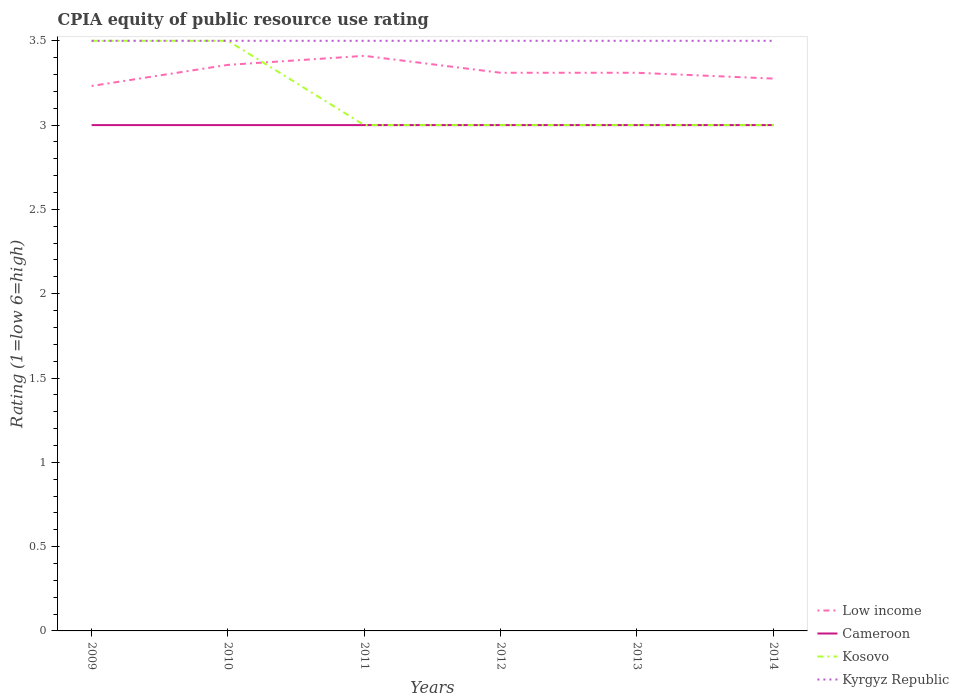How many different coloured lines are there?
Offer a terse response. 4. Is the number of lines equal to the number of legend labels?
Ensure brevity in your answer.  Yes. Across all years, what is the maximum CPIA rating in Cameroon?
Your answer should be very brief. 3. What is the total CPIA rating in Cameroon in the graph?
Provide a succinct answer. 0. What is the difference between the highest and the second highest CPIA rating in Kosovo?
Ensure brevity in your answer.  0.5. Is the CPIA rating in Kyrgyz Republic strictly greater than the CPIA rating in Cameroon over the years?
Your answer should be compact. No. Are the values on the major ticks of Y-axis written in scientific E-notation?
Keep it short and to the point. No. How many legend labels are there?
Provide a short and direct response. 4. What is the title of the graph?
Your response must be concise. CPIA equity of public resource use rating. What is the label or title of the X-axis?
Give a very brief answer. Years. What is the label or title of the Y-axis?
Offer a terse response. Rating (1=low 6=high). What is the Rating (1=low 6=high) in Low income in 2009?
Ensure brevity in your answer.  3.23. What is the Rating (1=low 6=high) of Cameroon in 2009?
Make the answer very short. 3. What is the Rating (1=low 6=high) of Low income in 2010?
Offer a very short reply. 3.36. What is the Rating (1=low 6=high) in Kyrgyz Republic in 2010?
Give a very brief answer. 3.5. What is the Rating (1=low 6=high) of Low income in 2011?
Provide a short and direct response. 3.41. What is the Rating (1=low 6=high) in Kyrgyz Republic in 2011?
Keep it short and to the point. 3.5. What is the Rating (1=low 6=high) in Low income in 2012?
Your answer should be very brief. 3.31. What is the Rating (1=low 6=high) of Cameroon in 2012?
Keep it short and to the point. 3. What is the Rating (1=low 6=high) of Kosovo in 2012?
Your answer should be compact. 3. What is the Rating (1=low 6=high) of Kyrgyz Republic in 2012?
Your answer should be very brief. 3.5. What is the Rating (1=low 6=high) in Low income in 2013?
Provide a short and direct response. 3.31. What is the Rating (1=low 6=high) in Kosovo in 2013?
Your answer should be very brief. 3. What is the Rating (1=low 6=high) of Kyrgyz Republic in 2013?
Give a very brief answer. 3.5. What is the Rating (1=low 6=high) in Low income in 2014?
Offer a very short reply. 3.28. What is the Rating (1=low 6=high) in Kosovo in 2014?
Make the answer very short. 3. What is the Rating (1=low 6=high) of Kyrgyz Republic in 2014?
Your response must be concise. 3.5. Across all years, what is the maximum Rating (1=low 6=high) in Low income?
Your answer should be compact. 3.41. Across all years, what is the maximum Rating (1=low 6=high) of Cameroon?
Make the answer very short. 3. Across all years, what is the minimum Rating (1=low 6=high) in Low income?
Keep it short and to the point. 3.23. Across all years, what is the minimum Rating (1=low 6=high) of Cameroon?
Keep it short and to the point. 3. Across all years, what is the minimum Rating (1=low 6=high) of Kyrgyz Republic?
Your response must be concise. 3.5. What is the total Rating (1=low 6=high) in Low income in the graph?
Your answer should be compact. 19.9. What is the total Rating (1=low 6=high) in Kyrgyz Republic in the graph?
Offer a very short reply. 21. What is the difference between the Rating (1=low 6=high) in Low income in 2009 and that in 2010?
Offer a very short reply. -0.12. What is the difference between the Rating (1=low 6=high) of Kosovo in 2009 and that in 2010?
Your answer should be very brief. 0. What is the difference between the Rating (1=low 6=high) of Kyrgyz Republic in 2009 and that in 2010?
Provide a short and direct response. 0. What is the difference between the Rating (1=low 6=high) of Low income in 2009 and that in 2011?
Keep it short and to the point. -0.18. What is the difference between the Rating (1=low 6=high) in Kosovo in 2009 and that in 2011?
Offer a very short reply. 0.5. What is the difference between the Rating (1=low 6=high) in Low income in 2009 and that in 2012?
Offer a terse response. -0.08. What is the difference between the Rating (1=low 6=high) in Cameroon in 2009 and that in 2012?
Offer a very short reply. 0. What is the difference between the Rating (1=low 6=high) in Kyrgyz Republic in 2009 and that in 2012?
Offer a terse response. 0. What is the difference between the Rating (1=low 6=high) of Low income in 2009 and that in 2013?
Give a very brief answer. -0.08. What is the difference between the Rating (1=low 6=high) in Cameroon in 2009 and that in 2013?
Your answer should be very brief. 0. What is the difference between the Rating (1=low 6=high) in Kosovo in 2009 and that in 2013?
Ensure brevity in your answer.  0.5. What is the difference between the Rating (1=low 6=high) of Kyrgyz Republic in 2009 and that in 2013?
Make the answer very short. 0. What is the difference between the Rating (1=low 6=high) of Low income in 2009 and that in 2014?
Keep it short and to the point. -0.04. What is the difference between the Rating (1=low 6=high) in Low income in 2010 and that in 2011?
Your response must be concise. -0.05. What is the difference between the Rating (1=low 6=high) in Kyrgyz Republic in 2010 and that in 2011?
Offer a terse response. 0. What is the difference between the Rating (1=low 6=high) in Low income in 2010 and that in 2012?
Provide a succinct answer. 0.05. What is the difference between the Rating (1=low 6=high) of Cameroon in 2010 and that in 2012?
Your response must be concise. 0. What is the difference between the Rating (1=low 6=high) in Kyrgyz Republic in 2010 and that in 2012?
Your answer should be compact. 0. What is the difference between the Rating (1=low 6=high) of Low income in 2010 and that in 2013?
Offer a terse response. 0.05. What is the difference between the Rating (1=low 6=high) in Cameroon in 2010 and that in 2013?
Make the answer very short. 0. What is the difference between the Rating (1=low 6=high) in Low income in 2010 and that in 2014?
Your answer should be very brief. 0.08. What is the difference between the Rating (1=low 6=high) in Kosovo in 2010 and that in 2014?
Your response must be concise. 0.5. What is the difference between the Rating (1=low 6=high) in Low income in 2011 and that in 2012?
Your answer should be compact. 0.1. What is the difference between the Rating (1=low 6=high) of Cameroon in 2011 and that in 2012?
Your response must be concise. 0. What is the difference between the Rating (1=low 6=high) of Low income in 2011 and that in 2013?
Your answer should be very brief. 0.1. What is the difference between the Rating (1=low 6=high) of Cameroon in 2011 and that in 2013?
Provide a short and direct response. 0. What is the difference between the Rating (1=low 6=high) in Kyrgyz Republic in 2011 and that in 2013?
Keep it short and to the point. 0. What is the difference between the Rating (1=low 6=high) in Low income in 2011 and that in 2014?
Your response must be concise. 0.13. What is the difference between the Rating (1=low 6=high) of Cameroon in 2011 and that in 2014?
Keep it short and to the point. 0. What is the difference between the Rating (1=low 6=high) in Kosovo in 2011 and that in 2014?
Offer a very short reply. 0. What is the difference between the Rating (1=low 6=high) in Kyrgyz Republic in 2011 and that in 2014?
Ensure brevity in your answer.  0. What is the difference between the Rating (1=low 6=high) in Kosovo in 2012 and that in 2013?
Ensure brevity in your answer.  0. What is the difference between the Rating (1=low 6=high) of Low income in 2012 and that in 2014?
Your answer should be compact. 0.03. What is the difference between the Rating (1=low 6=high) in Kosovo in 2012 and that in 2014?
Ensure brevity in your answer.  0. What is the difference between the Rating (1=low 6=high) in Low income in 2013 and that in 2014?
Keep it short and to the point. 0.03. What is the difference between the Rating (1=low 6=high) of Cameroon in 2013 and that in 2014?
Provide a short and direct response. 0. What is the difference between the Rating (1=low 6=high) of Kyrgyz Republic in 2013 and that in 2014?
Keep it short and to the point. 0. What is the difference between the Rating (1=low 6=high) of Low income in 2009 and the Rating (1=low 6=high) of Cameroon in 2010?
Provide a short and direct response. 0.23. What is the difference between the Rating (1=low 6=high) of Low income in 2009 and the Rating (1=low 6=high) of Kosovo in 2010?
Offer a terse response. -0.27. What is the difference between the Rating (1=low 6=high) of Low income in 2009 and the Rating (1=low 6=high) of Kyrgyz Republic in 2010?
Your response must be concise. -0.27. What is the difference between the Rating (1=low 6=high) in Kosovo in 2009 and the Rating (1=low 6=high) in Kyrgyz Republic in 2010?
Offer a terse response. 0. What is the difference between the Rating (1=low 6=high) of Low income in 2009 and the Rating (1=low 6=high) of Cameroon in 2011?
Provide a succinct answer. 0.23. What is the difference between the Rating (1=low 6=high) of Low income in 2009 and the Rating (1=low 6=high) of Kosovo in 2011?
Make the answer very short. 0.23. What is the difference between the Rating (1=low 6=high) of Low income in 2009 and the Rating (1=low 6=high) of Kyrgyz Republic in 2011?
Your response must be concise. -0.27. What is the difference between the Rating (1=low 6=high) of Cameroon in 2009 and the Rating (1=low 6=high) of Kosovo in 2011?
Offer a very short reply. 0. What is the difference between the Rating (1=low 6=high) of Cameroon in 2009 and the Rating (1=low 6=high) of Kyrgyz Republic in 2011?
Your answer should be very brief. -0.5. What is the difference between the Rating (1=low 6=high) of Kosovo in 2009 and the Rating (1=low 6=high) of Kyrgyz Republic in 2011?
Provide a short and direct response. 0. What is the difference between the Rating (1=low 6=high) of Low income in 2009 and the Rating (1=low 6=high) of Cameroon in 2012?
Ensure brevity in your answer.  0.23. What is the difference between the Rating (1=low 6=high) of Low income in 2009 and the Rating (1=low 6=high) of Kosovo in 2012?
Provide a succinct answer. 0.23. What is the difference between the Rating (1=low 6=high) in Low income in 2009 and the Rating (1=low 6=high) in Kyrgyz Republic in 2012?
Provide a short and direct response. -0.27. What is the difference between the Rating (1=low 6=high) of Cameroon in 2009 and the Rating (1=low 6=high) of Kyrgyz Republic in 2012?
Provide a short and direct response. -0.5. What is the difference between the Rating (1=low 6=high) in Low income in 2009 and the Rating (1=low 6=high) in Cameroon in 2013?
Keep it short and to the point. 0.23. What is the difference between the Rating (1=low 6=high) in Low income in 2009 and the Rating (1=low 6=high) in Kosovo in 2013?
Provide a short and direct response. 0.23. What is the difference between the Rating (1=low 6=high) of Low income in 2009 and the Rating (1=low 6=high) of Kyrgyz Republic in 2013?
Your answer should be compact. -0.27. What is the difference between the Rating (1=low 6=high) of Cameroon in 2009 and the Rating (1=low 6=high) of Kosovo in 2013?
Ensure brevity in your answer.  0. What is the difference between the Rating (1=low 6=high) in Cameroon in 2009 and the Rating (1=low 6=high) in Kyrgyz Republic in 2013?
Your response must be concise. -0.5. What is the difference between the Rating (1=low 6=high) in Low income in 2009 and the Rating (1=low 6=high) in Cameroon in 2014?
Give a very brief answer. 0.23. What is the difference between the Rating (1=low 6=high) of Low income in 2009 and the Rating (1=low 6=high) of Kosovo in 2014?
Ensure brevity in your answer.  0.23. What is the difference between the Rating (1=low 6=high) of Low income in 2009 and the Rating (1=low 6=high) of Kyrgyz Republic in 2014?
Your answer should be very brief. -0.27. What is the difference between the Rating (1=low 6=high) in Low income in 2010 and the Rating (1=low 6=high) in Cameroon in 2011?
Offer a terse response. 0.36. What is the difference between the Rating (1=low 6=high) of Low income in 2010 and the Rating (1=low 6=high) of Kosovo in 2011?
Your response must be concise. 0.36. What is the difference between the Rating (1=low 6=high) of Low income in 2010 and the Rating (1=low 6=high) of Kyrgyz Republic in 2011?
Your answer should be compact. -0.14. What is the difference between the Rating (1=low 6=high) of Cameroon in 2010 and the Rating (1=low 6=high) of Kosovo in 2011?
Ensure brevity in your answer.  0. What is the difference between the Rating (1=low 6=high) in Kosovo in 2010 and the Rating (1=low 6=high) in Kyrgyz Republic in 2011?
Your response must be concise. 0. What is the difference between the Rating (1=low 6=high) of Low income in 2010 and the Rating (1=low 6=high) of Cameroon in 2012?
Make the answer very short. 0.36. What is the difference between the Rating (1=low 6=high) of Low income in 2010 and the Rating (1=low 6=high) of Kosovo in 2012?
Keep it short and to the point. 0.36. What is the difference between the Rating (1=low 6=high) in Low income in 2010 and the Rating (1=low 6=high) in Kyrgyz Republic in 2012?
Your answer should be compact. -0.14. What is the difference between the Rating (1=low 6=high) in Cameroon in 2010 and the Rating (1=low 6=high) in Kyrgyz Republic in 2012?
Give a very brief answer. -0.5. What is the difference between the Rating (1=low 6=high) of Low income in 2010 and the Rating (1=low 6=high) of Cameroon in 2013?
Provide a succinct answer. 0.36. What is the difference between the Rating (1=low 6=high) of Low income in 2010 and the Rating (1=low 6=high) of Kosovo in 2013?
Offer a terse response. 0.36. What is the difference between the Rating (1=low 6=high) of Low income in 2010 and the Rating (1=low 6=high) of Kyrgyz Republic in 2013?
Make the answer very short. -0.14. What is the difference between the Rating (1=low 6=high) in Cameroon in 2010 and the Rating (1=low 6=high) in Kosovo in 2013?
Provide a short and direct response. 0. What is the difference between the Rating (1=low 6=high) in Kosovo in 2010 and the Rating (1=low 6=high) in Kyrgyz Republic in 2013?
Your answer should be compact. 0. What is the difference between the Rating (1=low 6=high) in Low income in 2010 and the Rating (1=low 6=high) in Cameroon in 2014?
Your response must be concise. 0.36. What is the difference between the Rating (1=low 6=high) in Low income in 2010 and the Rating (1=low 6=high) in Kosovo in 2014?
Ensure brevity in your answer.  0.36. What is the difference between the Rating (1=low 6=high) in Low income in 2010 and the Rating (1=low 6=high) in Kyrgyz Republic in 2014?
Make the answer very short. -0.14. What is the difference between the Rating (1=low 6=high) of Cameroon in 2010 and the Rating (1=low 6=high) of Kyrgyz Republic in 2014?
Your response must be concise. -0.5. What is the difference between the Rating (1=low 6=high) in Low income in 2011 and the Rating (1=low 6=high) in Cameroon in 2012?
Offer a very short reply. 0.41. What is the difference between the Rating (1=low 6=high) in Low income in 2011 and the Rating (1=low 6=high) in Kosovo in 2012?
Provide a succinct answer. 0.41. What is the difference between the Rating (1=low 6=high) in Low income in 2011 and the Rating (1=low 6=high) in Kyrgyz Republic in 2012?
Ensure brevity in your answer.  -0.09. What is the difference between the Rating (1=low 6=high) in Kosovo in 2011 and the Rating (1=low 6=high) in Kyrgyz Republic in 2012?
Ensure brevity in your answer.  -0.5. What is the difference between the Rating (1=low 6=high) in Low income in 2011 and the Rating (1=low 6=high) in Cameroon in 2013?
Keep it short and to the point. 0.41. What is the difference between the Rating (1=low 6=high) of Low income in 2011 and the Rating (1=low 6=high) of Kosovo in 2013?
Provide a short and direct response. 0.41. What is the difference between the Rating (1=low 6=high) in Low income in 2011 and the Rating (1=low 6=high) in Kyrgyz Republic in 2013?
Give a very brief answer. -0.09. What is the difference between the Rating (1=low 6=high) of Kosovo in 2011 and the Rating (1=low 6=high) of Kyrgyz Republic in 2013?
Make the answer very short. -0.5. What is the difference between the Rating (1=low 6=high) in Low income in 2011 and the Rating (1=low 6=high) in Cameroon in 2014?
Keep it short and to the point. 0.41. What is the difference between the Rating (1=low 6=high) in Low income in 2011 and the Rating (1=low 6=high) in Kosovo in 2014?
Your answer should be very brief. 0.41. What is the difference between the Rating (1=low 6=high) in Low income in 2011 and the Rating (1=low 6=high) in Kyrgyz Republic in 2014?
Offer a terse response. -0.09. What is the difference between the Rating (1=low 6=high) of Low income in 2012 and the Rating (1=low 6=high) of Cameroon in 2013?
Make the answer very short. 0.31. What is the difference between the Rating (1=low 6=high) of Low income in 2012 and the Rating (1=low 6=high) of Kosovo in 2013?
Give a very brief answer. 0.31. What is the difference between the Rating (1=low 6=high) of Low income in 2012 and the Rating (1=low 6=high) of Kyrgyz Republic in 2013?
Offer a terse response. -0.19. What is the difference between the Rating (1=low 6=high) of Cameroon in 2012 and the Rating (1=low 6=high) of Kyrgyz Republic in 2013?
Keep it short and to the point. -0.5. What is the difference between the Rating (1=low 6=high) in Kosovo in 2012 and the Rating (1=low 6=high) in Kyrgyz Republic in 2013?
Your answer should be compact. -0.5. What is the difference between the Rating (1=low 6=high) of Low income in 2012 and the Rating (1=low 6=high) of Cameroon in 2014?
Keep it short and to the point. 0.31. What is the difference between the Rating (1=low 6=high) in Low income in 2012 and the Rating (1=low 6=high) in Kosovo in 2014?
Offer a terse response. 0.31. What is the difference between the Rating (1=low 6=high) of Low income in 2012 and the Rating (1=low 6=high) of Kyrgyz Republic in 2014?
Offer a very short reply. -0.19. What is the difference between the Rating (1=low 6=high) of Kosovo in 2012 and the Rating (1=low 6=high) of Kyrgyz Republic in 2014?
Offer a very short reply. -0.5. What is the difference between the Rating (1=low 6=high) in Low income in 2013 and the Rating (1=low 6=high) in Cameroon in 2014?
Give a very brief answer. 0.31. What is the difference between the Rating (1=low 6=high) in Low income in 2013 and the Rating (1=low 6=high) in Kosovo in 2014?
Make the answer very short. 0.31. What is the difference between the Rating (1=low 6=high) in Low income in 2013 and the Rating (1=low 6=high) in Kyrgyz Republic in 2014?
Your answer should be compact. -0.19. What is the average Rating (1=low 6=high) of Low income per year?
Ensure brevity in your answer.  3.32. What is the average Rating (1=low 6=high) in Cameroon per year?
Provide a short and direct response. 3. What is the average Rating (1=low 6=high) in Kosovo per year?
Provide a short and direct response. 3.17. In the year 2009, what is the difference between the Rating (1=low 6=high) in Low income and Rating (1=low 6=high) in Cameroon?
Provide a short and direct response. 0.23. In the year 2009, what is the difference between the Rating (1=low 6=high) of Low income and Rating (1=low 6=high) of Kosovo?
Provide a short and direct response. -0.27. In the year 2009, what is the difference between the Rating (1=low 6=high) in Low income and Rating (1=low 6=high) in Kyrgyz Republic?
Make the answer very short. -0.27. In the year 2009, what is the difference between the Rating (1=low 6=high) of Cameroon and Rating (1=low 6=high) of Kosovo?
Ensure brevity in your answer.  -0.5. In the year 2009, what is the difference between the Rating (1=low 6=high) of Kosovo and Rating (1=low 6=high) of Kyrgyz Republic?
Offer a very short reply. 0. In the year 2010, what is the difference between the Rating (1=low 6=high) of Low income and Rating (1=low 6=high) of Cameroon?
Keep it short and to the point. 0.36. In the year 2010, what is the difference between the Rating (1=low 6=high) in Low income and Rating (1=low 6=high) in Kosovo?
Your answer should be compact. -0.14. In the year 2010, what is the difference between the Rating (1=low 6=high) in Low income and Rating (1=low 6=high) in Kyrgyz Republic?
Provide a succinct answer. -0.14. In the year 2010, what is the difference between the Rating (1=low 6=high) in Cameroon and Rating (1=low 6=high) in Kosovo?
Keep it short and to the point. -0.5. In the year 2011, what is the difference between the Rating (1=low 6=high) in Low income and Rating (1=low 6=high) in Cameroon?
Provide a short and direct response. 0.41. In the year 2011, what is the difference between the Rating (1=low 6=high) in Low income and Rating (1=low 6=high) in Kosovo?
Ensure brevity in your answer.  0.41. In the year 2011, what is the difference between the Rating (1=low 6=high) of Low income and Rating (1=low 6=high) of Kyrgyz Republic?
Provide a succinct answer. -0.09. In the year 2011, what is the difference between the Rating (1=low 6=high) of Cameroon and Rating (1=low 6=high) of Kosovo?
Give a very brief answer. 0. In the year 2012, what is the difference between the Rating (1=low 6=high) of Low income and Rating (1=low 6=high) of Cameroon?
Provide a short and direct response. 0.31. In the year 2012, what is the difference between the Rating (1=low 6=high) of Low income and Rating (1=low 6=high) of Kosovo?
Make the answer very short. 0.31. In the year 2012, what is the difference between the Rating (1=low 6=high) in Low income and Rating (1=low 6=high) in Kyrgyz Republic?
Ensure brevity in your answer.  -0.19. In the year 2012, what is the difference between the Rating (1=low 6=high) of Cameroon and Rating (1=low 6=high) of Kosovo?
Your answer should be very brief. 0. In the year 2012, what is the difference between the Rating (1=low 6=high) in Cameroon and Rating (1=low 6=high) in Kyrgyz Republic?
Provide a succinct answer. -0.5. In the year 2013, what is the difference between the Rating (1=low 6=high) of Low income and Rating (1=low 6=high) of Cameroon?
Provide a succinct answer. 0.31. In the year 2013, what is the difference between the Rating (1=low 6=high) of Low income and Rating (1=low 6=high) of Kosovo?
Your answer should be compact. 0.31. In the year 2013, what is the difference between the Rating (1=low 6=high) in Low income and Rating (1=low 6=high) in Kyrgyz Republic?
Provide a succinct answer. -0.19. In the year 2014, what is the difference between the Rating (1=low 6=high) in Low income and Rating (1=low 6=high) in Cameroon?
Give a very brief answer. 0.28. In the year 2014, what is the difference between the Rating (1=low 6=high) of Low income and Rating (1=low 6=high) of Kosovo?
Offer a terse response. 0.28. In the year 2014, what is the difference between the Rating (1=low 6=high) in Low income and Rating (1=low 6=high) in Kyrgyz Republic?
Provide a short and direct response. -0.22. In the year 2014, what is the difference between the Rating (1=low 6=high) of Cameroon and Rating (1=low 6=high) of Kosovo?
Give a very brief answer. 0. In the year 2014, what is the difference between the Rating (1=low 6=high) of Cameroon and Rating (1=low 6=high) of Kyrgyz Republic?
Give a very brief answer. -0.5. In the year 2014, what is the difference between the Rating (1=low 6=high) in Kosovo and Rating (1=low 6=high) in Kyrgyz Republic?
Provide a succinct answer. -0.5. What is the ratio of the Rating (1=low 6=high) of Low income in 2009 to that in 2010?
Make the answer very short. 0.96. What is the ratio of the Rating (1=low 6=high) in Kyrgyz Republic in 2009 to that in 2010?
Make the answer very short. 1. What is the ratio of the Rating (1=low 6=high) in Low income in 2009 to that in 2011?
Provide a succinct answer. 0.95. What is the ratio of the Rating (1=low 6=high) in Cameroon in 2009 to that in 2011?
Your answer should be compact. 1. What is the ratio of the Rating (1=low 6=high) of Kyrgyz Republic in 2009 to that in 2011?
Give a very brief answer. 1. What is the ratio of the Rating (1=low 6=high) of Low income in 2009 to that in 2012?
Give a very brief answer. 0.98. What is the ratio of the Rating (1=low 6=high) of Cameroon in 2009 to that in 2012?
Make the answer very short. 1. What is the ratio of the Rating (1=low 6=high) in Kyrgyz Republic in 2009 to that in 2012?
Offer a terse response. 1. What is the ratio of the Rating (1=low 6=high) of Low income in 2009 to that in 2013?
Your answer should be very brief. 0.98. What is the ratio of the Rating (1=low 6=high) in Kosovo in 2009 to that in 2013?
Keep it short and to the point. 1.17. What is the ratio of the Rating (1=low 6=high) of Kyrgyz Republic in 2009 to that in 2013?
Your answer should be compact. 1. What is the ratio of the Rating (1=low 6=high) of Low income in 2009 to that in 2014?
Your answer should be compact. 0.99. What is the ratio of the Rating (1=low 6=high) in Cameroon in 2009 to that in 2014?
Ensure brevity in your answer.  1. What is the ratio of the Rating (1=low 6=high) in Low income in 2010 to that in 2011?
Offer a very short reply. 0.98. What is the ratio of the Rating (1=low 6=high) in Cameroon in 2010 to that in 2011?
Ensure brevity in your answer.  1. What is the ratio of the Rating (1=low 6=high) of Low income in 2010 to that in 2012?
Make the answer very short. 1.01. What is the ratio of the Rating (1=low 6=high) of Cameroon in 2010 to that in 2012?
Your answer should be compact. 1. What is the ratio of the Rating (1=low 6=high) of Low income in 2010 to that in 2013?
Ensure brevity in your answer.  1.01. What is the ratio of the Rating (1=low 6=high) in Low income in 2010 to that in 2014?
Your answer should be compact. 1.02. What is the ratio of the Rating (1=low 6=high) in Cameroon in 2010 to that in 2014?
Your answer should be compact. 1. What is the ratio of the Rating (1=low 6=high) of Kyrgyz Republic in 2010 to that in 2014?
Provide a succinct answer. 1. What is the ratio of the Rating (1=low 6=high) of Low income in 2011 to that in 2012?
Your answer should be very brief. 1.03. What is the ratio of the Rating (1=low 6=high) in Cameroon in 2011 to that in 2012?
Your response must be concise. 1. What is the ratio of the Rating (1=low 6=high) of Low income in 2011 to that in 2013?
Provide a succinct answer. 1.03. What is the ratio of the Rating (1=low 6=high) in Kosovo in 2011 to that in 2013?
Give a very brief answer. 1. What is the ratio of the Rating (1=low 6=high) in Kyrgyz Republic in 2011 to that in 2013?
Give a very brief answer. 1. What is the ratio of the Rating (1=low 6=high) of Low income in 2011 to that in 2014?
Give a very brief answer. 1.04. What is the ratio of the Rating (1=low 6=high) in Cameroon in 2011 to that in 2014?
Provide a short and direct response. 1. What is the ratio of the Rating (1=low 6=high) in Kyrgyz Republic in 2011 to that in 2014?
Your answer should be very brief. 1. What is the ratio of the Rating (1=low 6=high) in Cameroon in 2012 to that in 2013?
Keep it short and to the point. 1. What is the ratio of the Rating (1=low 6=high) in Kosovo in 2012 to that in 2013?
Provide a succinct answer. 1. What is the ratio of the Rating (1=low 6=high) of Low income in 2012 to that in 2014?
Your answer should be compact. 1.01. What is the ratio of the Rating (1=low 6=high) of Kosovo in 2012 to that in 2014?
Make the answer very short. 1. What is the ratio of the Rating (1=low 6=high) of Low income in 2013 to that in 2014?
Ensure brevity in your answer.  1.01. What is the ratio of the Rating (1=low 6=high) in Cameroon in 2013 to that in 2014?
Offer a terse response. 1. What is the ratio of the Rating (1=low 6=high) in Kyrgyz Republic in 2013 to that in 2014?
Offer a terse response. 1. What is the difference between the highest and the second highest Rating (1=low 6=high) in Low income?
Ensure brevity in your answer.  0.05. What is the difference between the highest and the second highest Rating (1=low 6=high) of Kosovo?
Give a very brief answer. 0. What is the difference between the highest and the lowest Rating (1=low 6=high) of Low income?
Your response must be concise. 0.18. What is the difference between the highest and the lowest Rating (1=low 6=high) in Kyrgyz Republic?
Your answer should be compact. 0. 